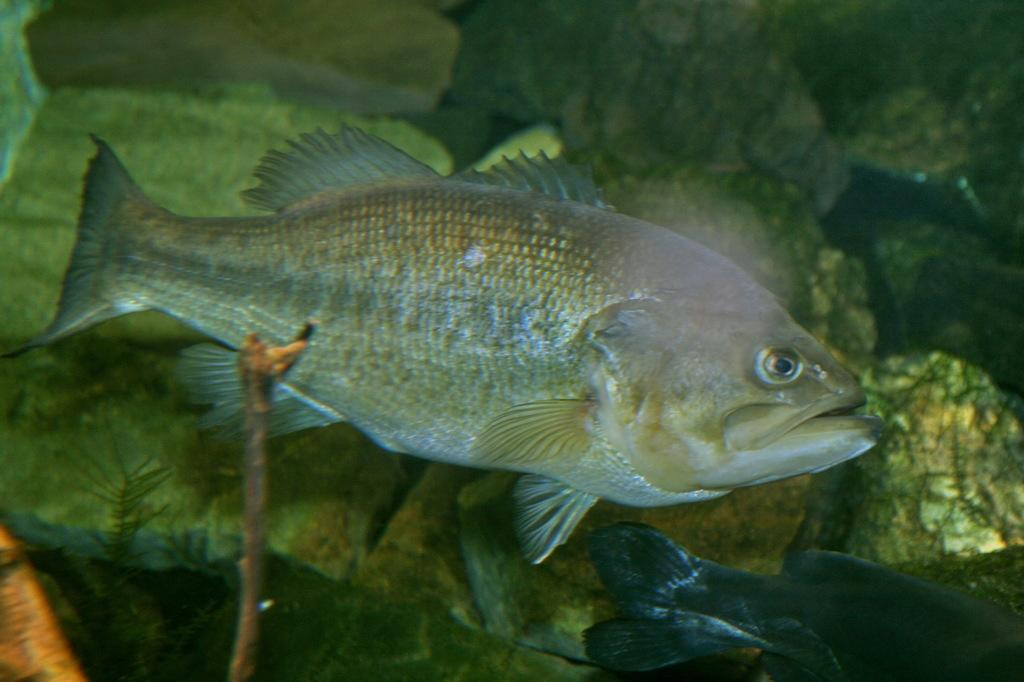What is the main subject in the center of the image? There is a fish in the center of the image. What other object can be seen in the image? There is a stick in the image. What type of spark can be seen coming from the fish in the image? There is no spark present in the image; it is a fish and a stick. What is the fish cooking in the image? The fish is not cooking anything in the image; it is simply a fish in the center of the image. 